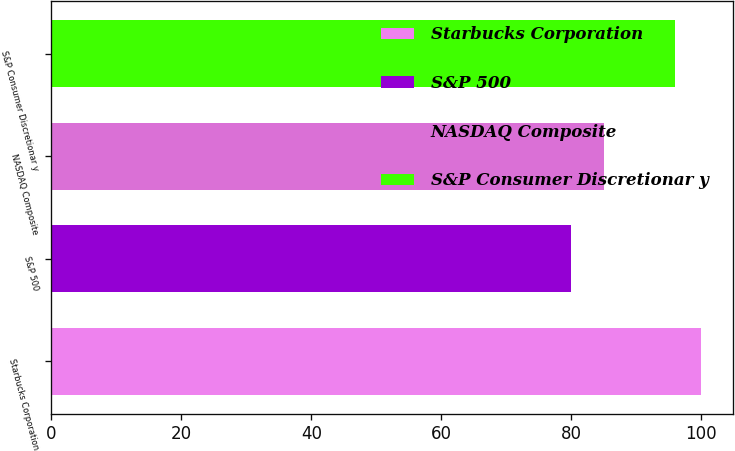Convert chart. <chart><loc_0><loc_0><loc_500><loc_500><bar_chart><fcel>Starbucks Corporation<fcel>S&P 500<fcel>NASDAQ Composite<fcel>S&P Consumer Discretionar y<nl><fcel>99.93<fcel>80.01<fcel>84.99<fcel>95.87<nl></chart> 